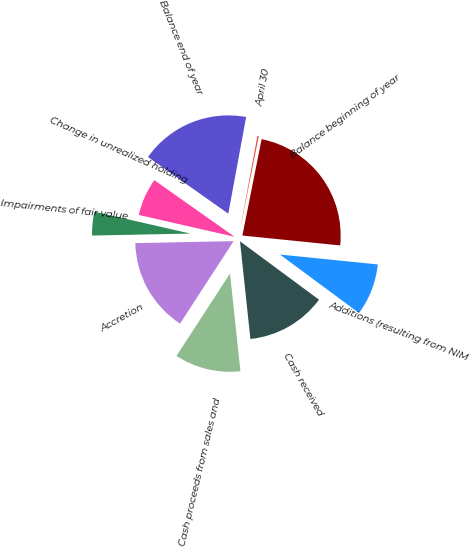Convert chart. <chart><loc_0><loc_0><loc_500><loc_500><pie_chart><fcel>April 30<fcel>Balance beginning of year<fcel>Additions (resulting from NIM<fcel>Cash received<fcel>Cash proceeds from sales and<fcel>Accretion<fcel>Impairments of fair value<fcel>Change in unrealized holding<fcel>Balance end of year<nl><fcel>0.23%<fcel>23.47%<fcel>8.53%<fcel>13.18%<fcel>10.86%<fcel>15.51%<fcel>3.89%<fcel>6.21%<fcel>18.13%<nl></chart> 